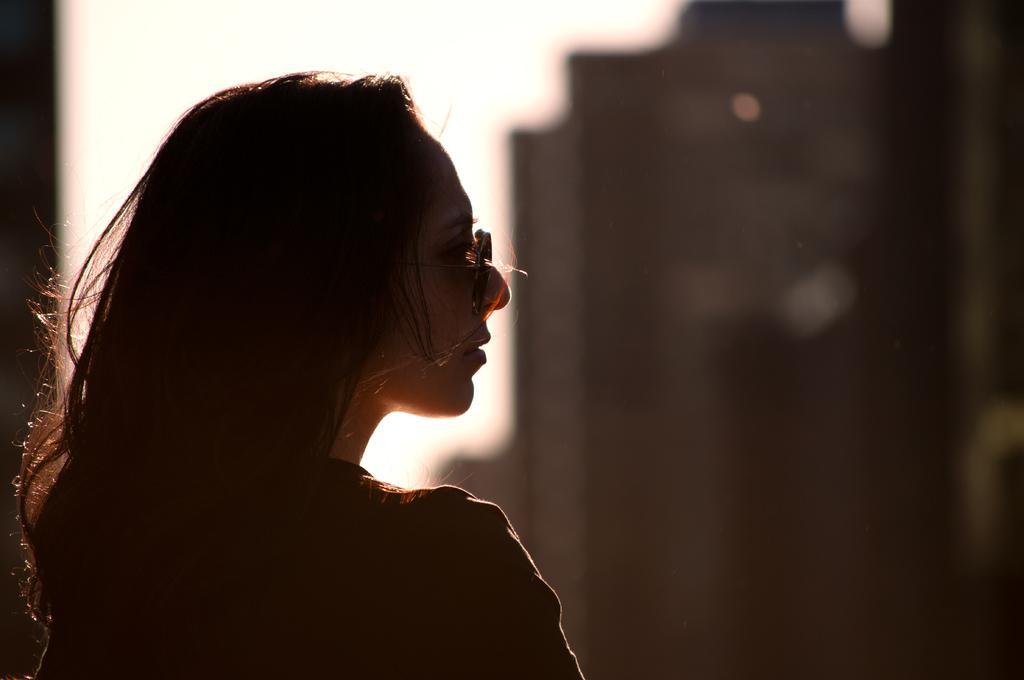Can you describe this image briefly? In this image we can see a woman. There is a blur background and we can see sky. 